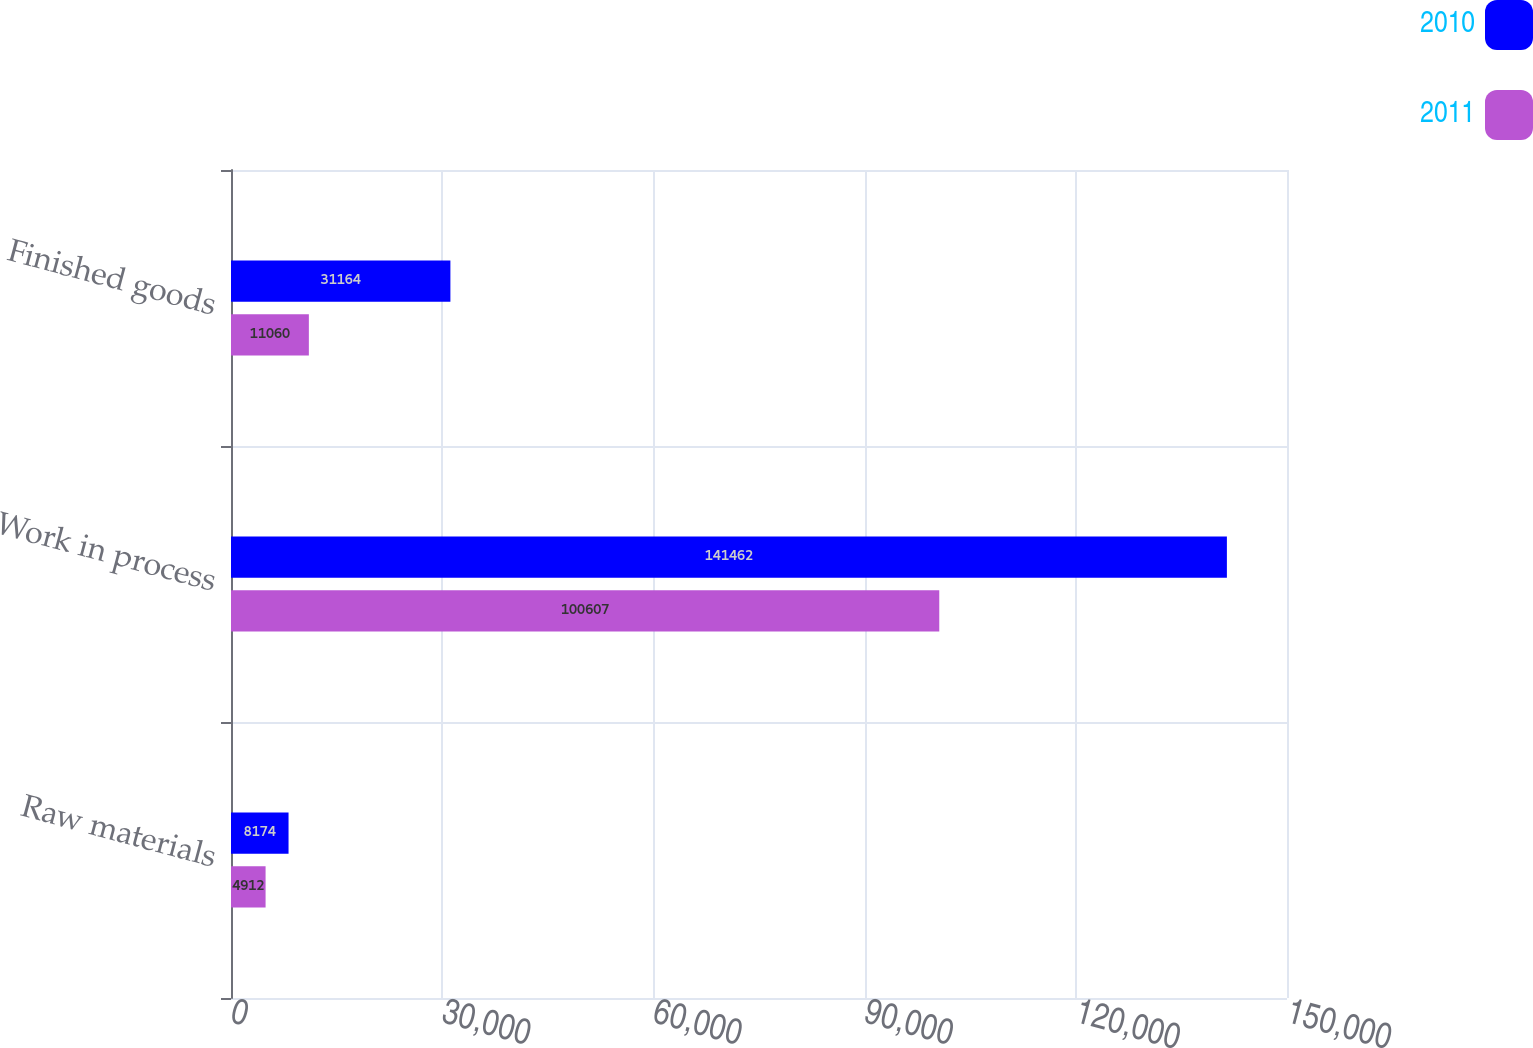Convert chart. <chart><loc_0><loc_0><loc_500><loc_500><stacked_bar_chart><ecel><fcel>Raw materials<fcel>Work in process<fcel>Finished goods<nl><fcel>2010<fcel>8174<fcel>141462<fcel>31164<nl><fcel>2011<fcel>4912<fcel>100607<fcel>11060<nl></chart> 